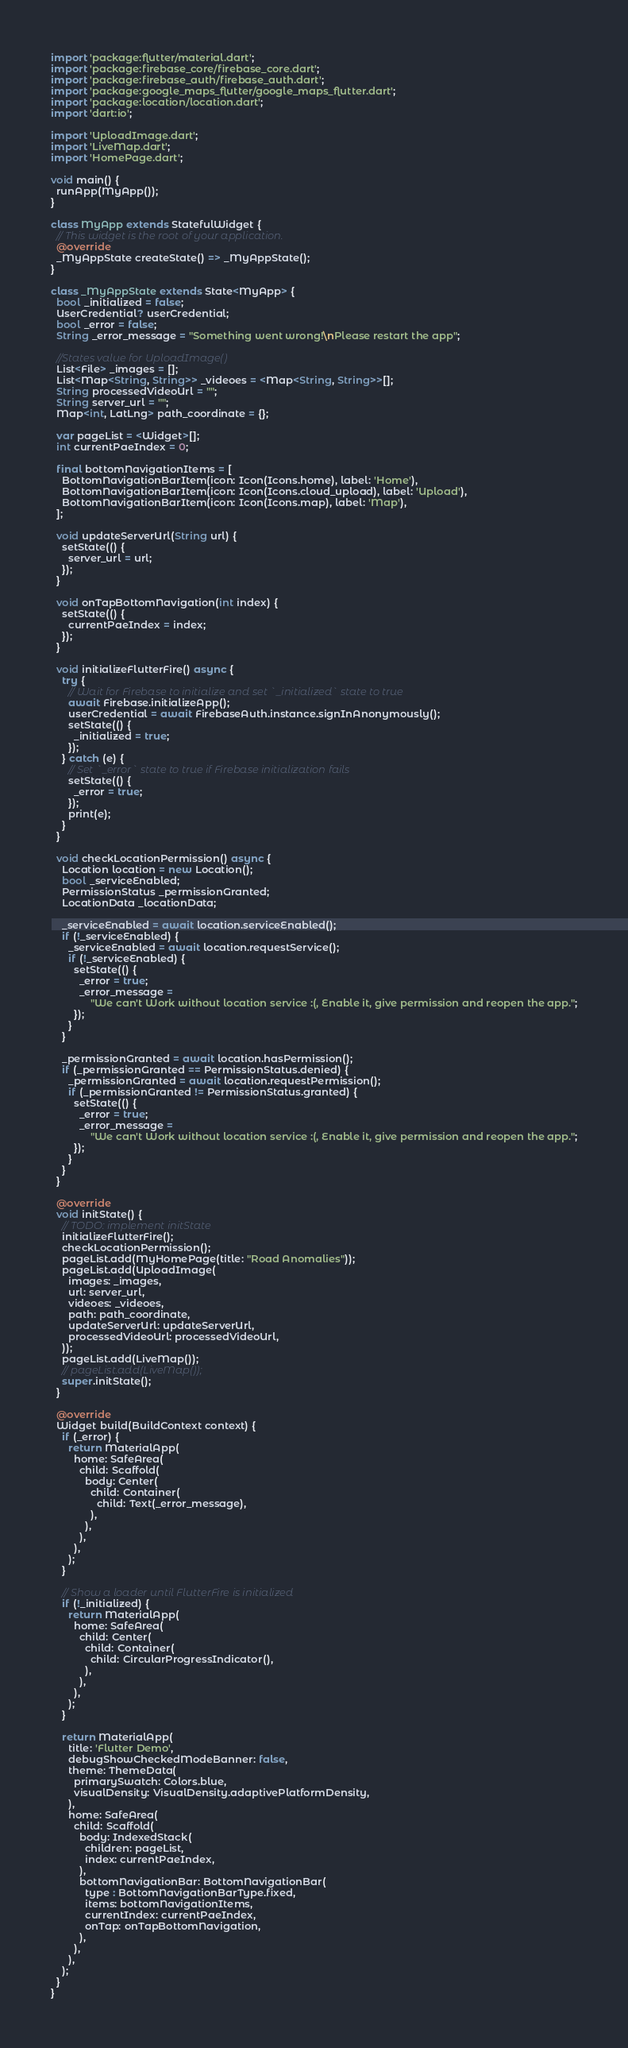Convert code to text. <code><loc_0><loc_0><loc_500><loc_500><_Dart_>import 'package:flutter/material.dart';
import 'package:firebase_core/firebase_core.dart';
import 'package:firebase_auth/firebase_auth.dart';
import 'package:google_maps_flutter/google_maps_flutter.dart';
import 'package:location/location.dart';
import 'dart:io';

import 'UploadImage.dart';
import 'LiveMap.dart';
import 'HomePage.dart';

void main() {
  runApp(MyApp());
}

class MyApp extends StatefulWidget {
  // This widget is the root of your application.
  @override
  _MyAppState createState() => _MyAppState();
}

class _MyAppState extends State<MyApp> {
  bool _initialized = false;
  UserCredential? userCredential;
  bool _error = false;
  String _error_message = "Something went wrong!\nPlease restart the app";

  //States value for UploadImage()
  List<File> _images = [];
  List<Map<String, String>> _videoes = <Map<String, String>>[];
  String processedVideoUrl = "";
  String server_url = "";
  Map<int, LatLng> path_coordinate = {};

  var pageList = <Widget>[];
  int currentPaeIndex = 0;

  final bottomNavigationItems = [
    BottomNavigationBarItem(icon: Icon(Icons.home), label: 'Home'),
    BottomNavigationBarItem(icon: Icon(Icons.cloud_upload), label: 'Upload'),
    BottomNavigationBarItem(icon: Icon(Icons.map), label: 'Map'),
  ];

  void updateServerUrl(String url) {
    setState(() {
      server_url = url;
    });
  }

  void onTapBottomNavigation(int index) {
    setState(() {
      currentPaeIndex = index;
    });
  }

  void initializeFlutterFire() async {
    try {
      // Wait for Firebase to initialize and set `_initialized` state to true
      await Firebase.initializeApp();
      userCredential = await FirebaseAuth.instance.signInAnonymously();
      setState(() {
        _initialized = true;
      });
    } catch (e) {
      // Set `_error` state to true if Firebase initialization fails
      setState(() {
        _error = true;
      });
      print(e);
    }
  }

  void checkLocationPermission() async {
    Location location = new Location();
    bool _serviceEnabled;
    PermissionStatus _permissionGranted;
    LocationData _locationData;

    _serviceEnabled = await location.serviceEnabled();
    if (!_serviceEnabled) {
      _serviceEnabled = await location.requestService();
      if (!_serviceEnabled) {
        setState(() {
          _error = true;
          _error_message =
              "We can't Work without location service :(, Enable it, give permission and reopen the app.";
        });
      }
    }

    _permissionGranted = await location.hasPermission();
    if (_permissionGranted == PermissionStatus.denied) {
      _permissionGranted = await location.requestPermission();
      if (_permissionGranted != PermissionStatus.granted) {
        setState(() {
          _error = true;
          _error_message =
              "We can't Work without location service :(, Enable it, give permission and reopen the app.";
        });
      }
    }
  }

  @override
  void initState() {
    // TODO: implement initState
    initializeFlutterFire();
    checkLocationPermission();
    pageList.add(MyHomePage(title: "Road Anomalies"));
    pageList.add(UploadImage(
      images: _images,
      url: server_url,
      videoes: _videoes,
      path: path_coordinate,
      updateServerUrl: updateServerUrl,
      processedVideoUrl: processedVideoUrl,
    ));
    pageList.add(LiveMap());
    // pageList.add(LiveMap());
    super.initState();
  }

  @override
  Widget build(BuildContext context) {
    if (_error) {
      return MaterialApp(
        home: SafeArea(
          child: Scaffold(
            body: Center(
              child: Container(
                child: Text(_error_message),
              ),
            ),
          ),
        ),
      );
    }

    // Show a loader until FlutterFire is initialized
    if (!_initialized) {
      return MaterialApp(
        home: SafeArea(
          child: Center(
            child: Container(
              child: CircularProgressIndicator(),
            ),
          ),
        ),
      );
    }

    return MaterialApp(
      title: 'Flutter Demo',
      debugShowCheckedModeBanner: false,
      theme: ThemeData(
        primarySwatch: Colors.blue,
        visualDensity: VisualDensity.adaptivePlatformDensity,
      ),
      home: SafeArea(
        child: Scaffold(
          body: IndexedStack(
            children: pageList,
            index: currentPaeIndex,
          ),
          bottomNavigationBar: BottomNavigationBar(
            type : BottomNavigationBarType.fixed,
            items: bottomNavigationItems,
            currentIndex: currentPaeIndex,
            onTap: onTapBottomNavigation,
          ),
        ),
      ),
    );
  }
}
</code> 